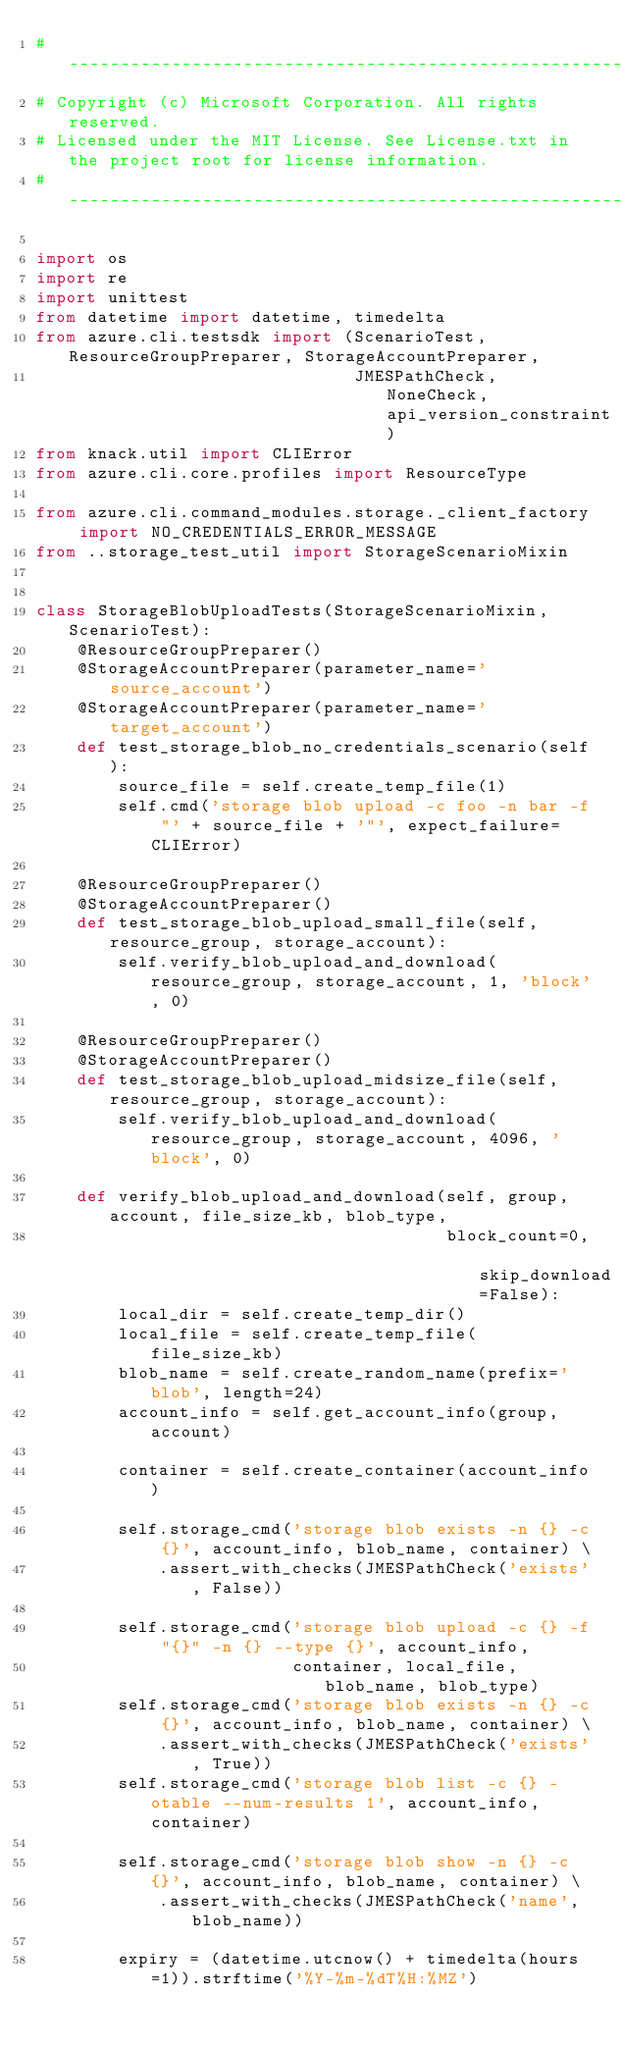<code> <loc_0><loc_0><loc_500><loc_500><_Python_># --------------------------------------------------------------------------------------------
# Copyright (c) Microsoft Corporation. All rights reserved.
# Licensed under the MIT License. See License.txt in the project root for license information.
# --------------------------------------------------------------------------------------------

import os
import re
import unittest
from datetime import datetime, timedelta
from azure.cli.testsdk import (ScenarioTest, ResourceGroupPreparer, StorageAccountPreparer,
                               JMESPathCheck, NoneCheck, api_version_constraint)
from knack.util import CLIError
from azure.cli.core.profiles import ResourceType

from azure.cli.command_modules.storage._client_factory import NO_CREDENTIALS_ERROR_MESSAGE
from ..storage_test_util import StorageScenarioMixin


class StorageBlobUploadTests(StorageScenarioMixin, ScenarioTest):
    @ResourceGroupPreparer()
    @StorageAccountPreparer(parameter_name='source_account')
    @StorageAccountPreparer(parameter_name='target_account')
    def test_storage_blob_no_credentials_scenario(self):
        source_file = self.create_temp_file(1)
        self.cmd('storage blob upload -c foo -n bar -f "' + source_file + '"', expect_failure=CLIError)

    @ResourceGroupPreparer()
    @StorageAccountPreparer()
    def test_storage_blob_upload_small_file(self, resource_group, storage_account):
        self.verify_blob_upload_and_download(resource_group, storage_account, 1, 'block', 0)

    @ResourceGroupPreparer()
    @StorageAccountPreparer()
    def test_storage_blob_upload_midsize_file(self, resource_group, storage_account):
        self.verify_blob_upload_and_download(resource_group, storage_account, 4096, 'block', 0)

    def verify_blob_upload_and_download(self, group, account, file_size_kb, blob_type,
                                        block_count=0, skip_download=False):
        local_dir = self.create_temp_dir()
        local_file = self.create_temp_file(file_size_kb)
        blob_name = self.create_random_name(prefix='blob', length=24)
        account_info = self.get_account_info(group, account)

        container = self.create_container(account_info)

        self.storage_cmd('storage blob exists -n {} -c {}', account_info, blob_name, container) \
            .assert_with_checks(JMESPathCheck('exists', False))

        self.storage_cmd('storage blob upload -c {} -f "{}" -n {} --type {}', account_info,
                         container, local_file, blob_name, blob_type)
        self.storage_cmd('storage blob exists -n {} -c {}', account_info, blob_name, container) \
            .assert_with_checks(JMESPathCheck('exists', True))
        self.storage_cmd('storage blob list -c {} -otable --num-results 1', account_info, container)

        self.storage_cmd('storage blob show -n {} -c {}', account_info, blob_name, container) \
            .assert_with_checks(JMESPathCheck('name', blob_name))

        expiry = (datetime.utcnow() + timedelta(hours=1)).strftime('%Y-%m-%dT%H:%MZ')</code> 